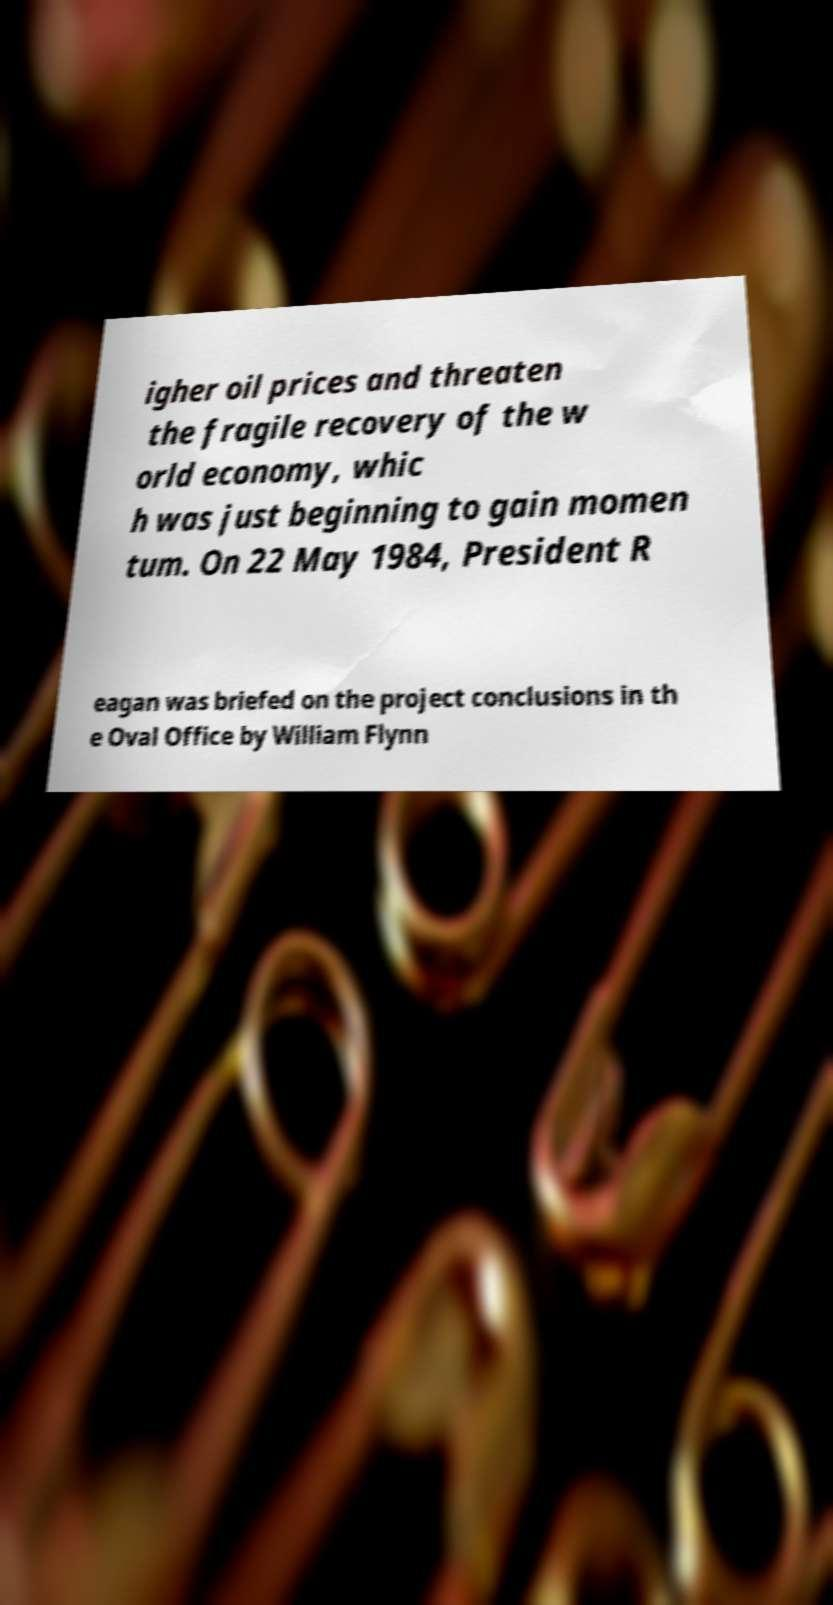What messages or text are displayed in this image? I need them in a readable, typed format. igher oil prices and threaten the fragile recovery of the w orld economy, whic h was just beginning to gain momen tum. On 22 May 1984, President R eagan was briefed on the project conclusions in th e Oval Office by William Flynn 